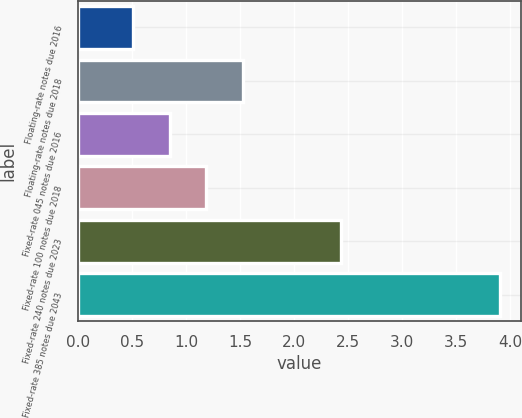Convert chart. <chart><loc_0><loc_0><loc_500><loc_500><bar_chart><fcel>Floating-rate notes due 2016<fcel>Floating-rate notes due 2018<fcel>Fixed-rate 045 notes due 2016<fcel>Fixed-rate 100 notes due 2018<fcel>Fixed-rate 240 notes due 2023<fcel>Fixed-rate 385 notes due 2043<nl><fcel>0.51<fcel>1.53<fcel>0.85<fcel>1.19<fcel>2.44<fcel>3.91<nl></chart> 